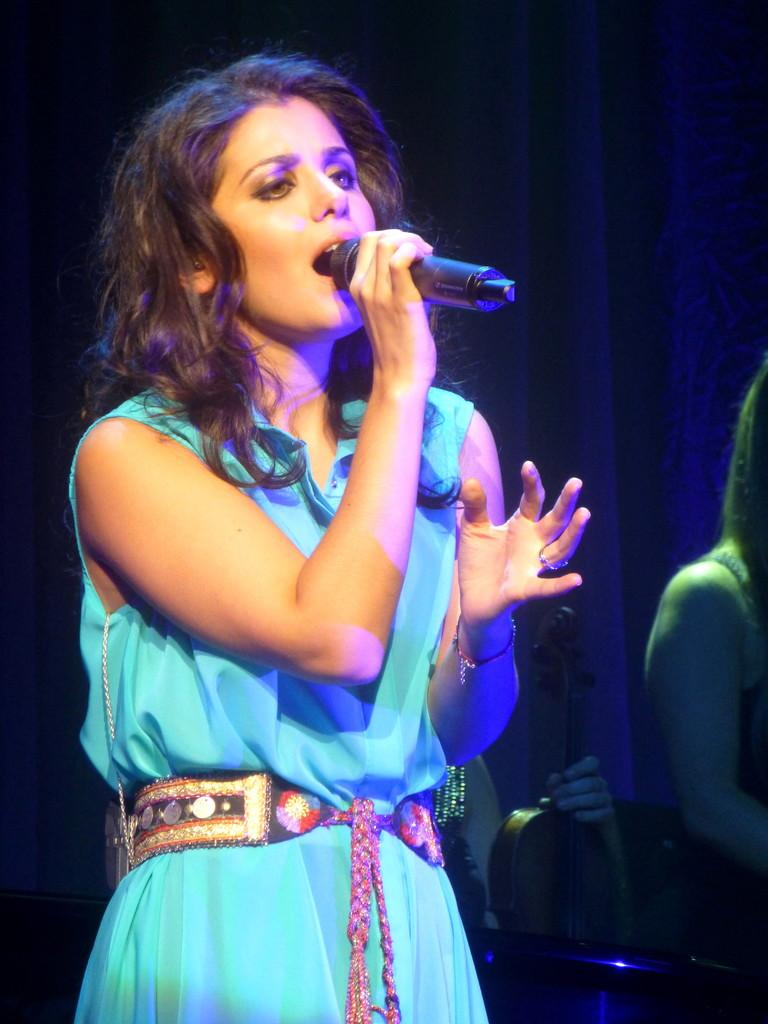Who is the main subject in the image? There is a woman in the image. What is the woman holding in the image? The woman is holding a microphone. What is the woman doing in the image? The woman is singing. Can you describe the people on the right side of the image? There are people on the right side of the image, and one person is holding a violin. What can be seen in the background of the image? There is cloth visible in the background of the image. How many legs can be seen swimming in the image? There are no legs visible in the image, let alone swimming. 